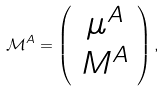<formula> <loc_0><loc_0><loc_500><loc_500>\mathcal { M } ^ { A } = \left ( \begin{array} { c } \mu ^ { A } \\ M ^ { A } \end{array} \right ) ,</formula> 